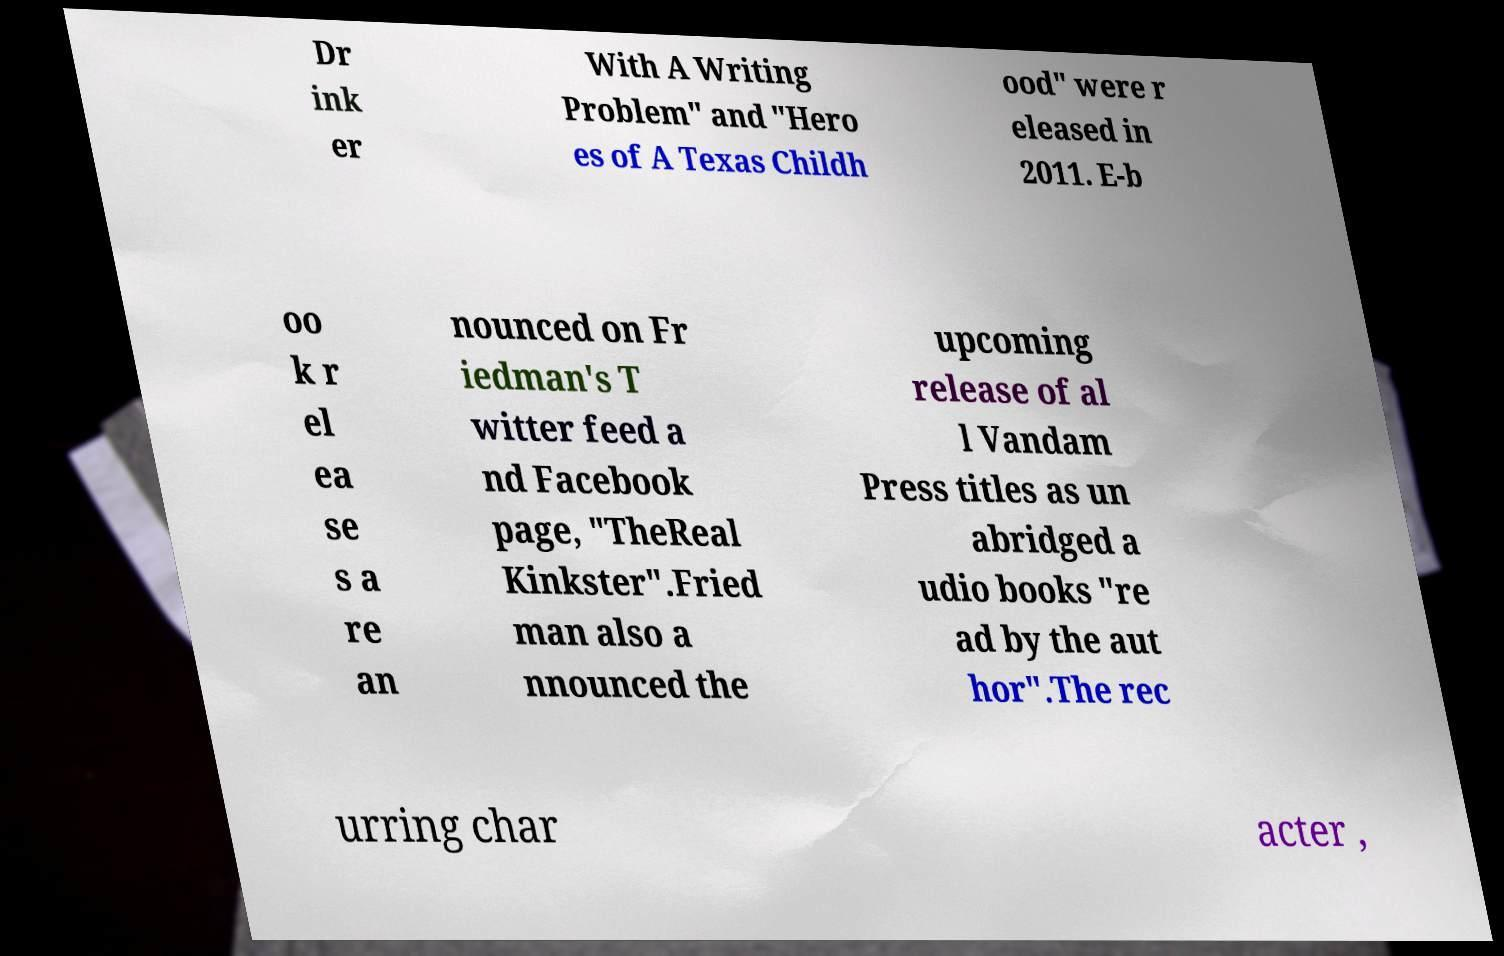Can you accurately transcribe the text from the provided image for me? Dr ink er With A Writing Problem" and "Hero es of A Texas Childh ood" were r eleased in 2011. E-b oo k r el ea se s a re an nounced on Fr iedman's T witter feed a nd Facebook page, "TheReal Kinkster".Fried man also a nnounced the upcoming release of al l Vandam Press titles as un abridged a udio books "re ad by the aut hor".The rec urring char acter , 